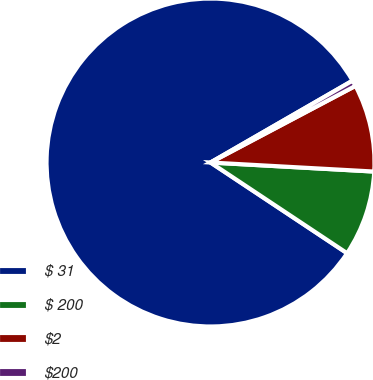Convert chart to OTSL. <chart><loc_0><loc_0><loc_500><loc_500><pie_chart><fcel>$ 31<fcel>$ 200<fcel>$2<fcel>$200<nl><fcel>82.35%<fcel>8.45%<fcel>8.62%<fcel>0.58%<nl></chart> 